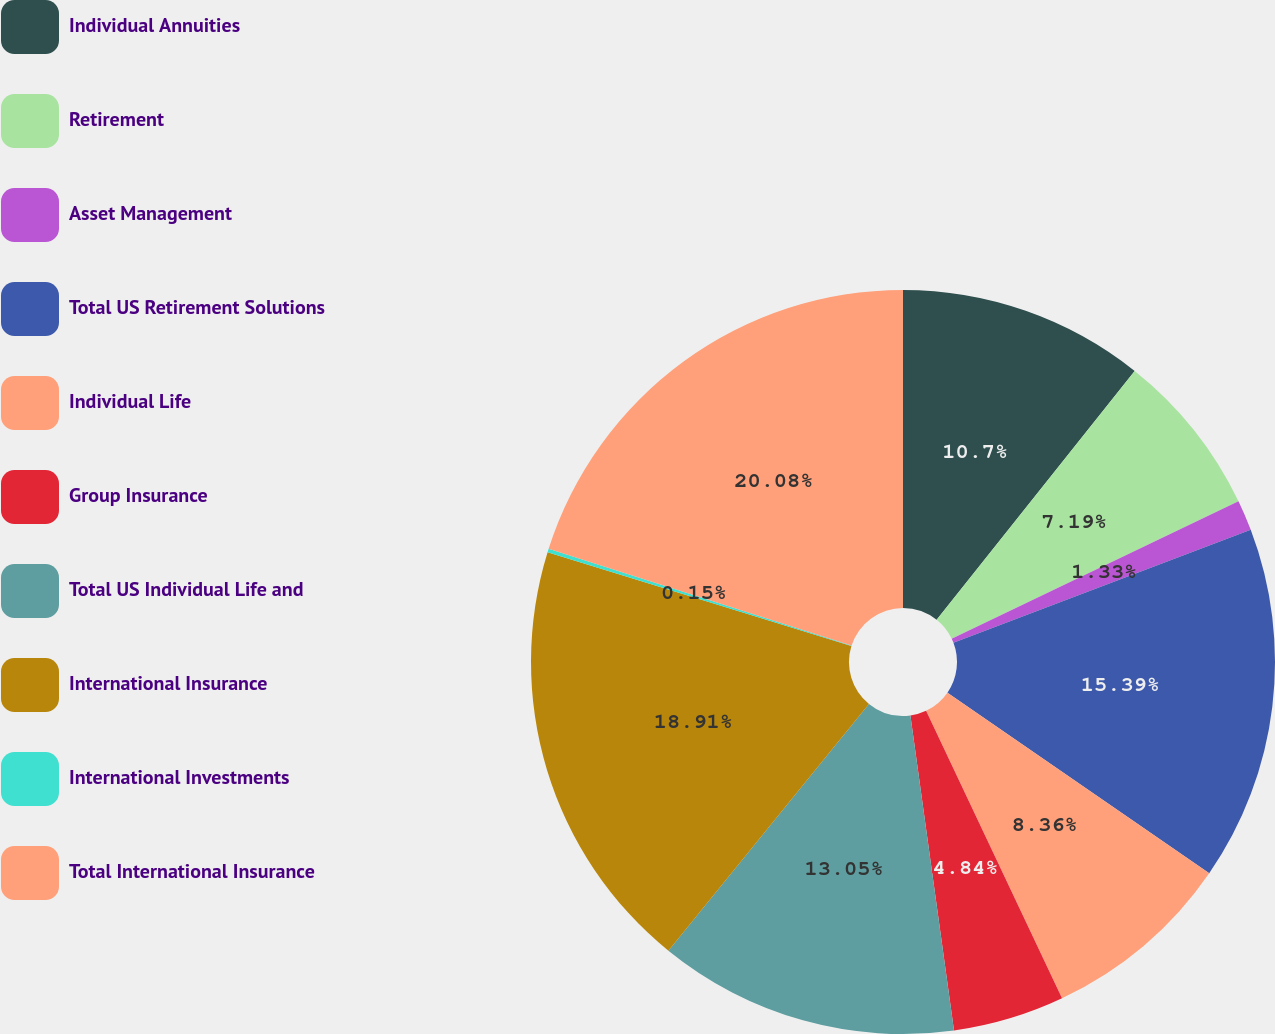<chart> <loc_0><loc_0><loc_500><loc_500><pie_chart><fcel>Individual Annuities<fcel>Retirement<fcel>Asset Management<fcel>Total US Retirement Solutions<fcel>Individual Life<fcel>Group Insurance<fcel>Total US Individual Life and<fcel>International Insurance<fcel>International Investments<fcel>Total International Insurance<nl><fcel>10.7%<fcel>7.19%<fcel>1.33%<fcel>15.39%<fcel>8.36%<fcel>4.84%<fcel>13.05%<fcel>18.91%<fcel>0.15%<fcel>20.08%<nl></chart> 